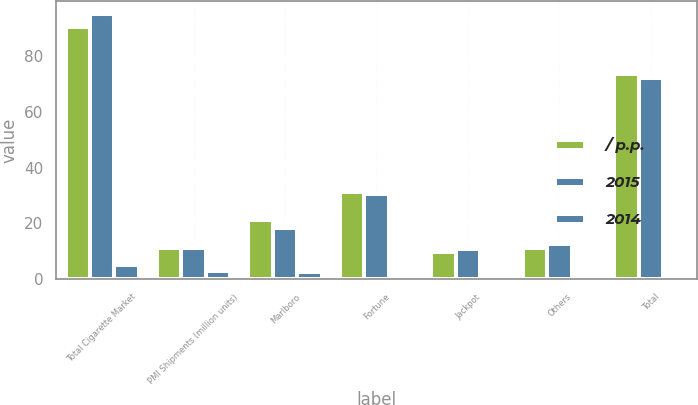Convert chart to OTSL. <chart><loc_0><loc_0><loc_500><loc_500><stacked_bar_chart><ecel><fcel>Total Cigarette Market<fcel>PMI Shipments (million units)<fcel>Marlboro<fcel>Fortune<fcel>Jackpot<fcel>Others<fcel>Total<nl><fcel>/ p.p.<fcel>90.2<fcel>11.3<fcel>21.1<fcel>31.1<fcel>9.9<fcel>11.3<fcel>73.4<nl><fcel>2015<fcel>94.9<fcel>11.3<fcel>18.4<fcel>30.4<fcel>10.7<fcel>12.5<fcel>72<nl><fcel>2014<fcel>4.9<fcel>3.1<fcel>2.7<fcel>0.7<fcel>0.8<fcel>1.2<fcel>1.4<nl></chart> 